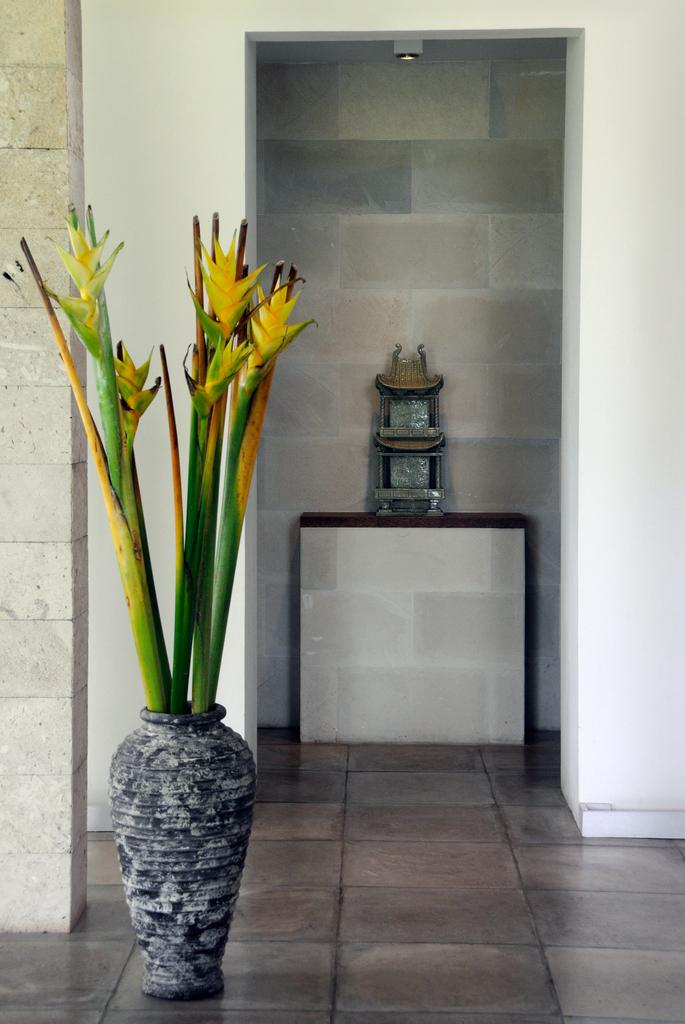What is the main object on display in the image? There is an object on a pedestal in the image. Can you describe any other objects in the image? There is a flower vase in the image. What can be seen in the background of the image? There are walls visible in the background of the image. How many pigs are playing on the sofa in the image? There are no pigs or sofa present in the image. 